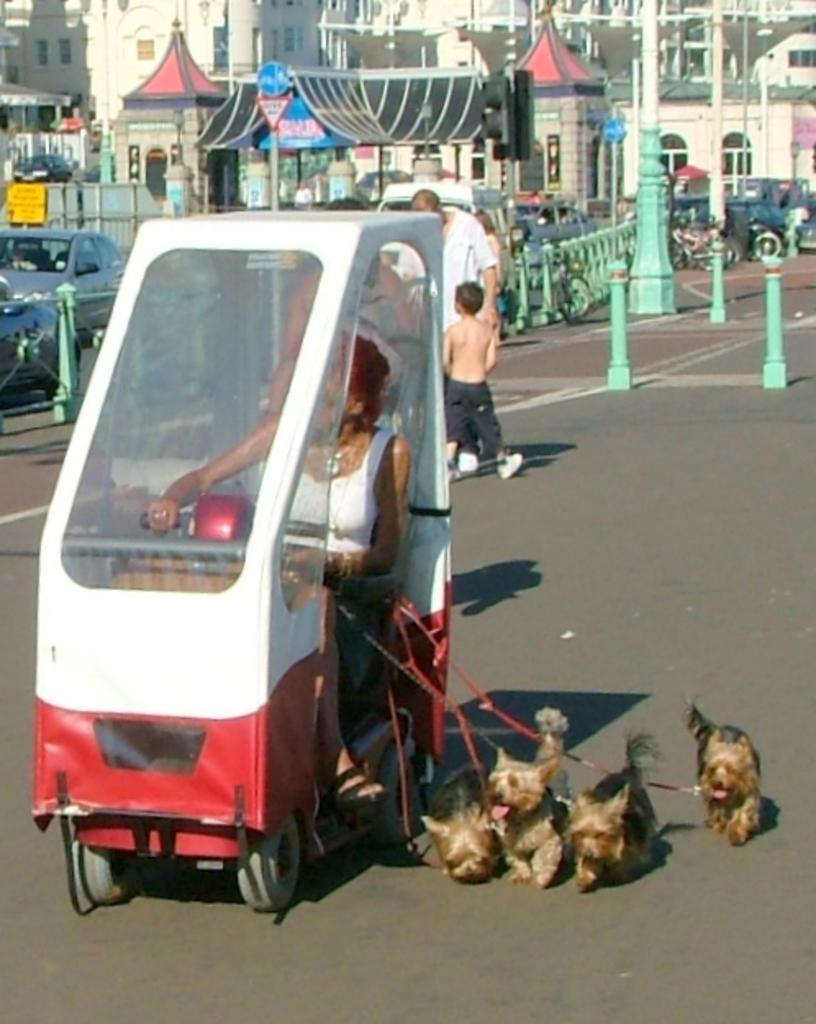What is the person in the image doing? The person is sitting in a vehicle. What is the person holding in the image? The person is holding belts. What are the belts attached to? The belts are attached to dogs. How many dogs are beside the person? There are dogs beside the person. What can be seen in the background of the image? There are buildings and vehicles in the background. What type of edge can be seen on the dogs in the image? There is no mention of an edge on the dogs in the image. The dogs are wearing belts, but there is no indication of any edge. 